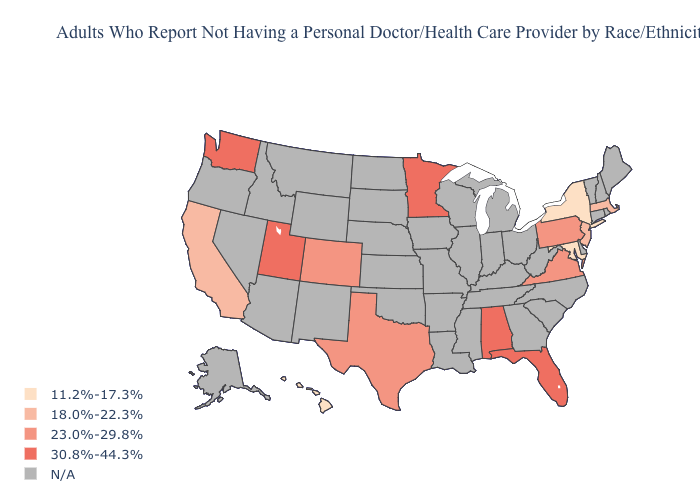What is the value of New Mexico?
Give a very brief answer. N/A. Does the map have missing data?
Keep it brief. Yes. What is the value of New Mexico?
Short answer required. N/A. Which states have the lowest value in the USA?
Short answer required. Hawaii, Maryland, New York. Name the states that have a value in the range 18.0%-22.3%?
Quick response, please. California, Massachusetts, New Jersey. Which states have the lowest value in the USA?
Concise answer only. Hawaii, Maryland, New York. Name the states that have a value in the range N/A?
Keep it brief. Alaska, Arizona, Arkansas, Connecticut, Delaware, Georgia, Idaho, Illinois, Indiana, Iowa, Kansas, Kentucky, Louisiana, Maine, Michigan, Mississippi, Missouri, Montana, Nebraska, Nevada, New Hampshire, New Mexico, North Carolina, North Dakota, Ohio, Oklahoma, Oregon, Rhode Island, South Carolina, South Dakota, Tennessee, Vermont, West Virginia, Wisconsin, Wyoming. What is the value of Montana?
Quick response, please. N/A. What is the highest value in the MidWest ?
Quick response, please. 30.8%-44.3%. What is the value of New Jersey?
Keep it brief. 18.0%-22.3%. 